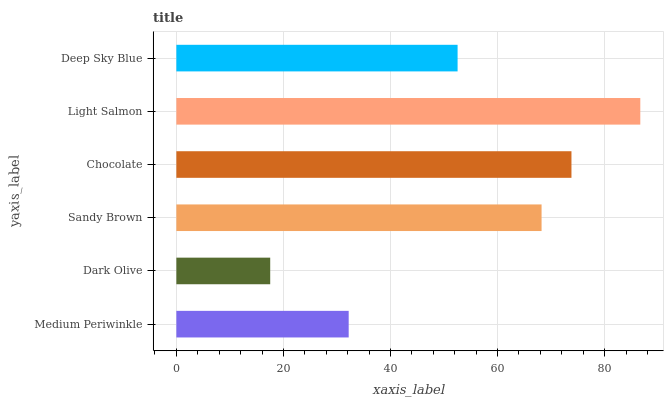Is Dark Olive the minimum?
Answer yes or no. Yes. Is Light Salmon the maximum?
Answer yes or no. Yes. Is Sandy Brown the minimum?
Answer yes or no. No. Is Sandy Brown the maximum?
Answer yes or no. No. Is Sandy Brown greater than Dark Olive?
Answer yes or no. Yes. Is Dark Olive less than Sandy Brown?
Answer yes or no. Yes. Is Dark Olive greater than Sandy Brown?
Answer yes or no. No. Is Sandy Brown less than Dark Olive?
Answer yes or no. No. Is Sandy Brown the high median?
Answer yes or no. Yes. Is Deep Sky Blue the low median?
Answer yes or no. Yes. Is Deep Sky Blue the high median?
Answer yes or no. No. Is Chocolate the low median?
Answer yes or no. No. 